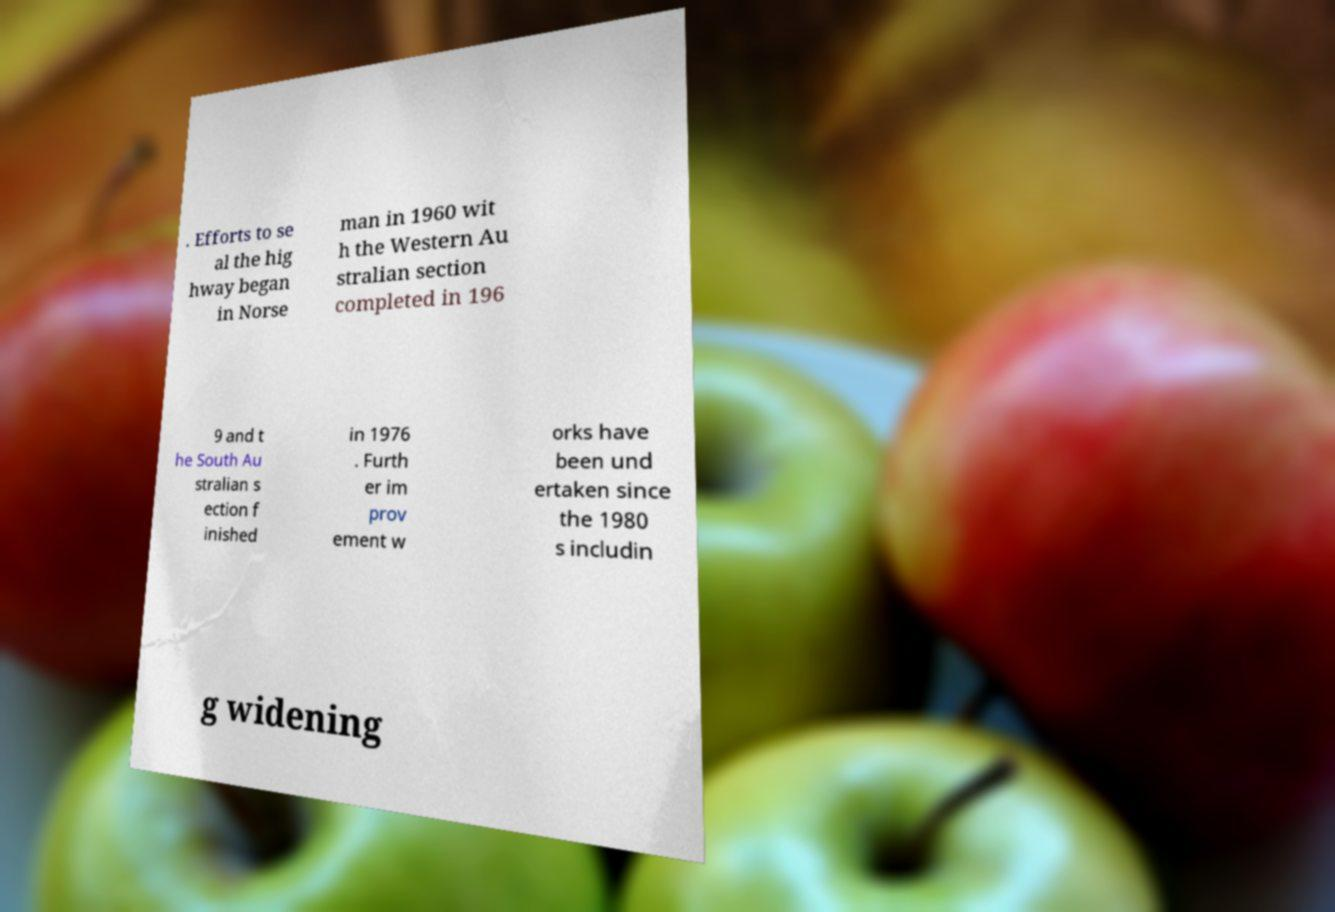What messages or text are displayed in this image? I need them in a readable, typed format. . Efforts to se al the hig hway began in Norse man in 1960 wit h the Western Au stralian section completed in 196 9 and t he South Au stralian s ection f inished in 1976 . Furth er im prov ement w orks have been und ertaken since the 1980 s includin g widening 